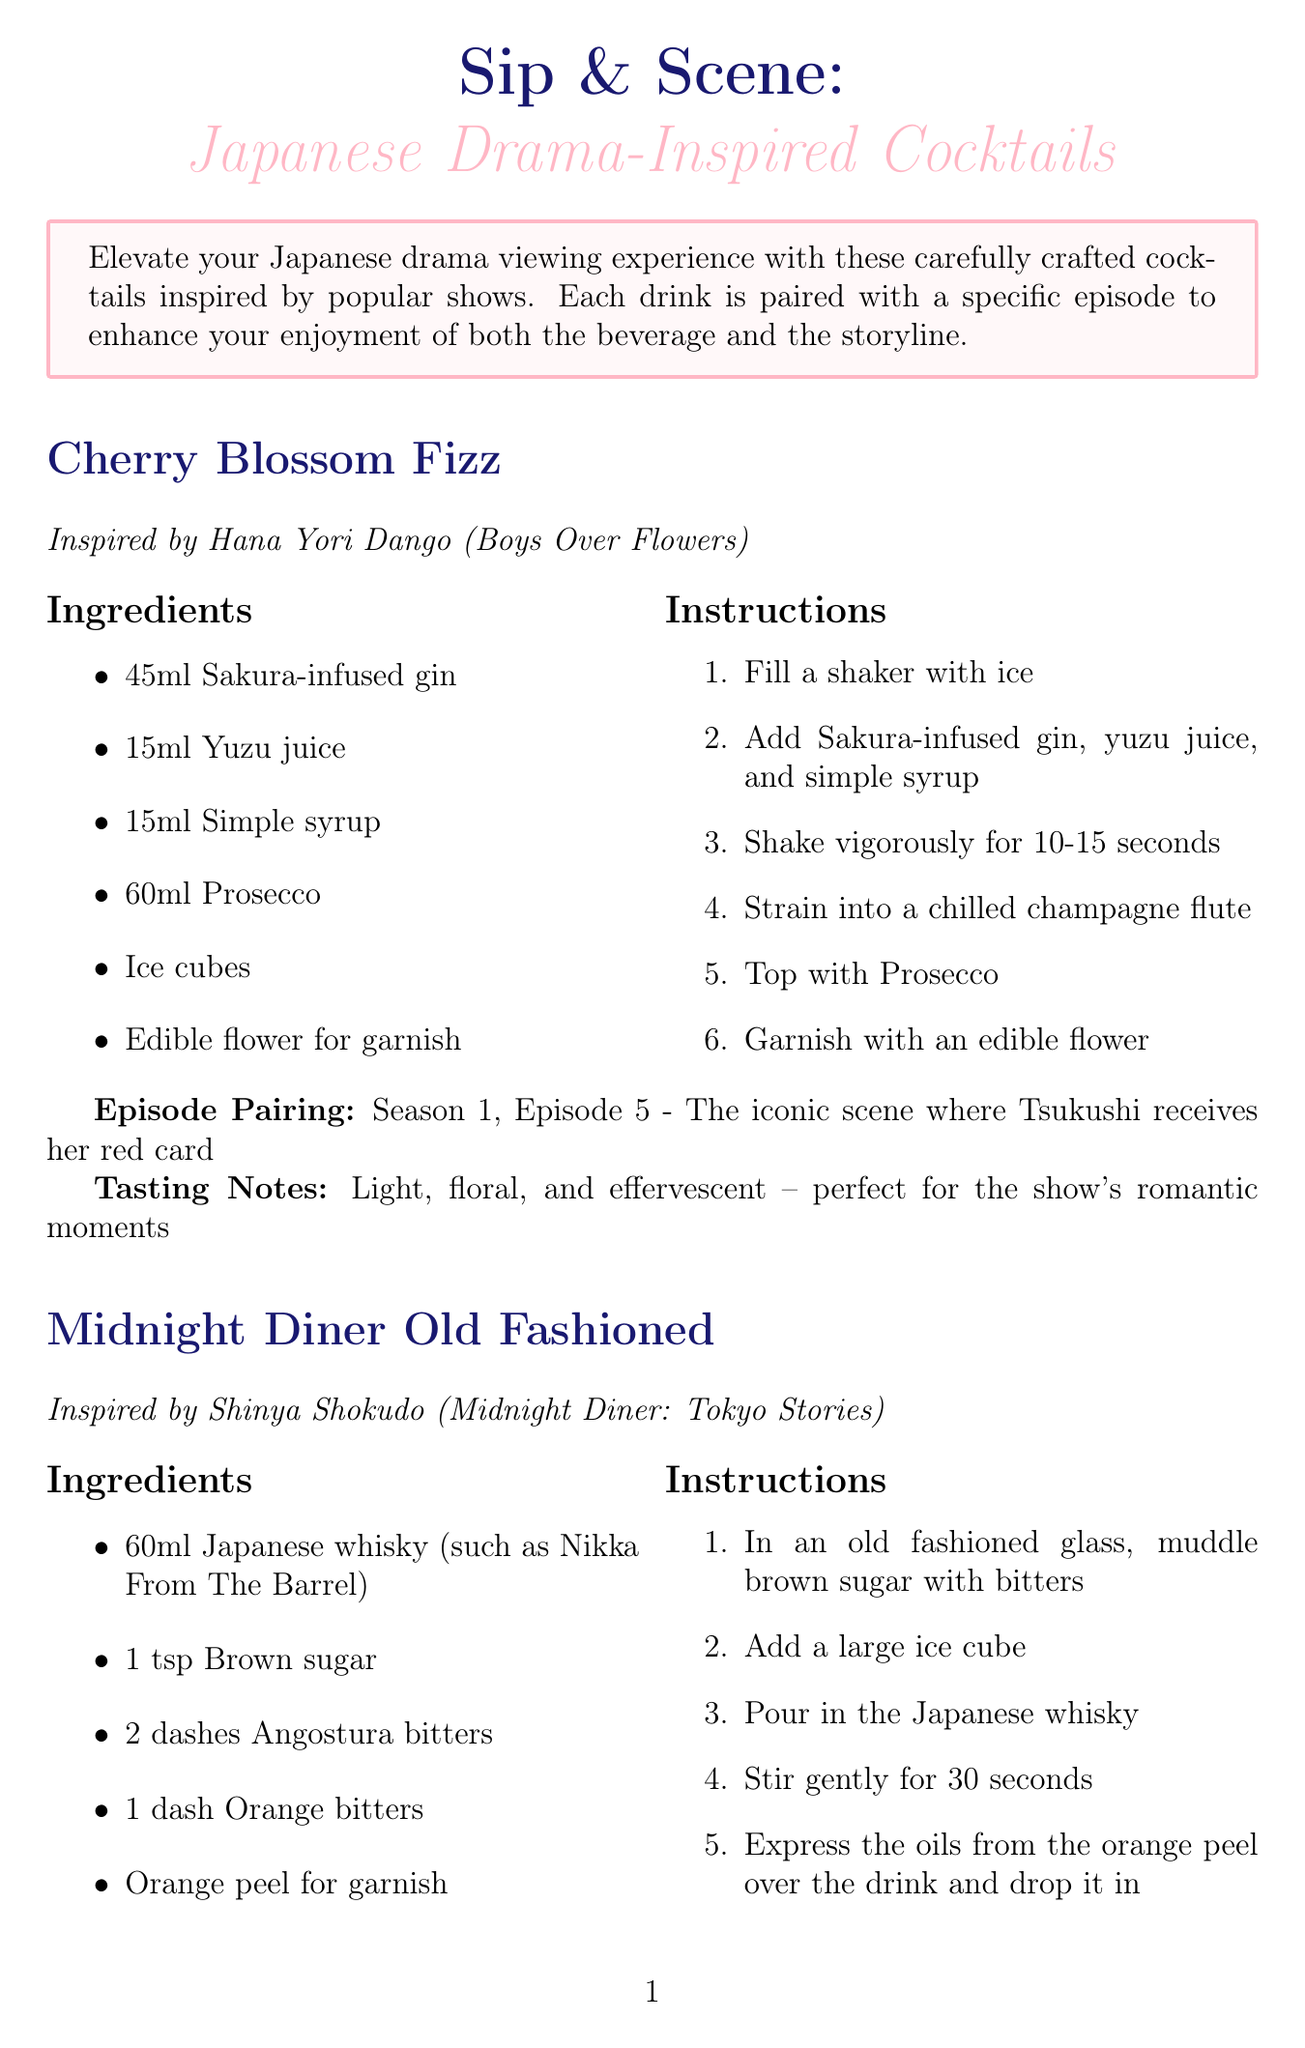What is the title of the newsletter? The title of the newsletter is stated at the beginning of the document as "Sip & Scene: Japanese Drama-Inspired Cocktails."
Answer: Sip & Scene: Japanese Drama-Inspired Cocktails How many cocktails are featured in the newsletter? The document lists three cocktails, which are "Cherry Blossom Fizz," "Midnight Diner Old Fashioned," and "Gokusen Punch."
Answer: 3 What is the main ingredient in the Cherry Blossom Fizz? The main ingredient for the Cherry Blossom Fizz cocktail is "Sakura-infused gin" according to the ingredients list.
Answer: Sakura-infused gin Which episode is paired with the Midnight Diner Old Fashioned? The specific episode pairing with the Midnight Diner Old Fashioned is mentioned in the document as "Season 1, Episode 3 - 'Butter Rice'."
Answer: Season 1, Episode 3 - 'Butter Rice' What food pairing is suggested for the Gokusen Punch? The document provides a specific food pairing for the Gokusen Punch, which is "Takoyaki."
Answer: Takoyaki What tasting notes are given for the Cherry Blossom Fizz? The tasting notes for the Cherry Blossom Fizz describe it as "Light, floral, and effervescent."
Answer: Light, floral, and effervescent What is the mixology tip mentioned in the newsletter? The tip advises using high-quality Japanese ingredients for authentic flavor and encourages experimentation with local fruits and spirits.
Answer: Use high-quality Japanese ingredients Which drama is recommended for newcomers to Japanese dramas? The document suggests starting with "Hana Yori Dango" as a classic rom-com experience for newcomers.
Answer: Hana Yori Dango 